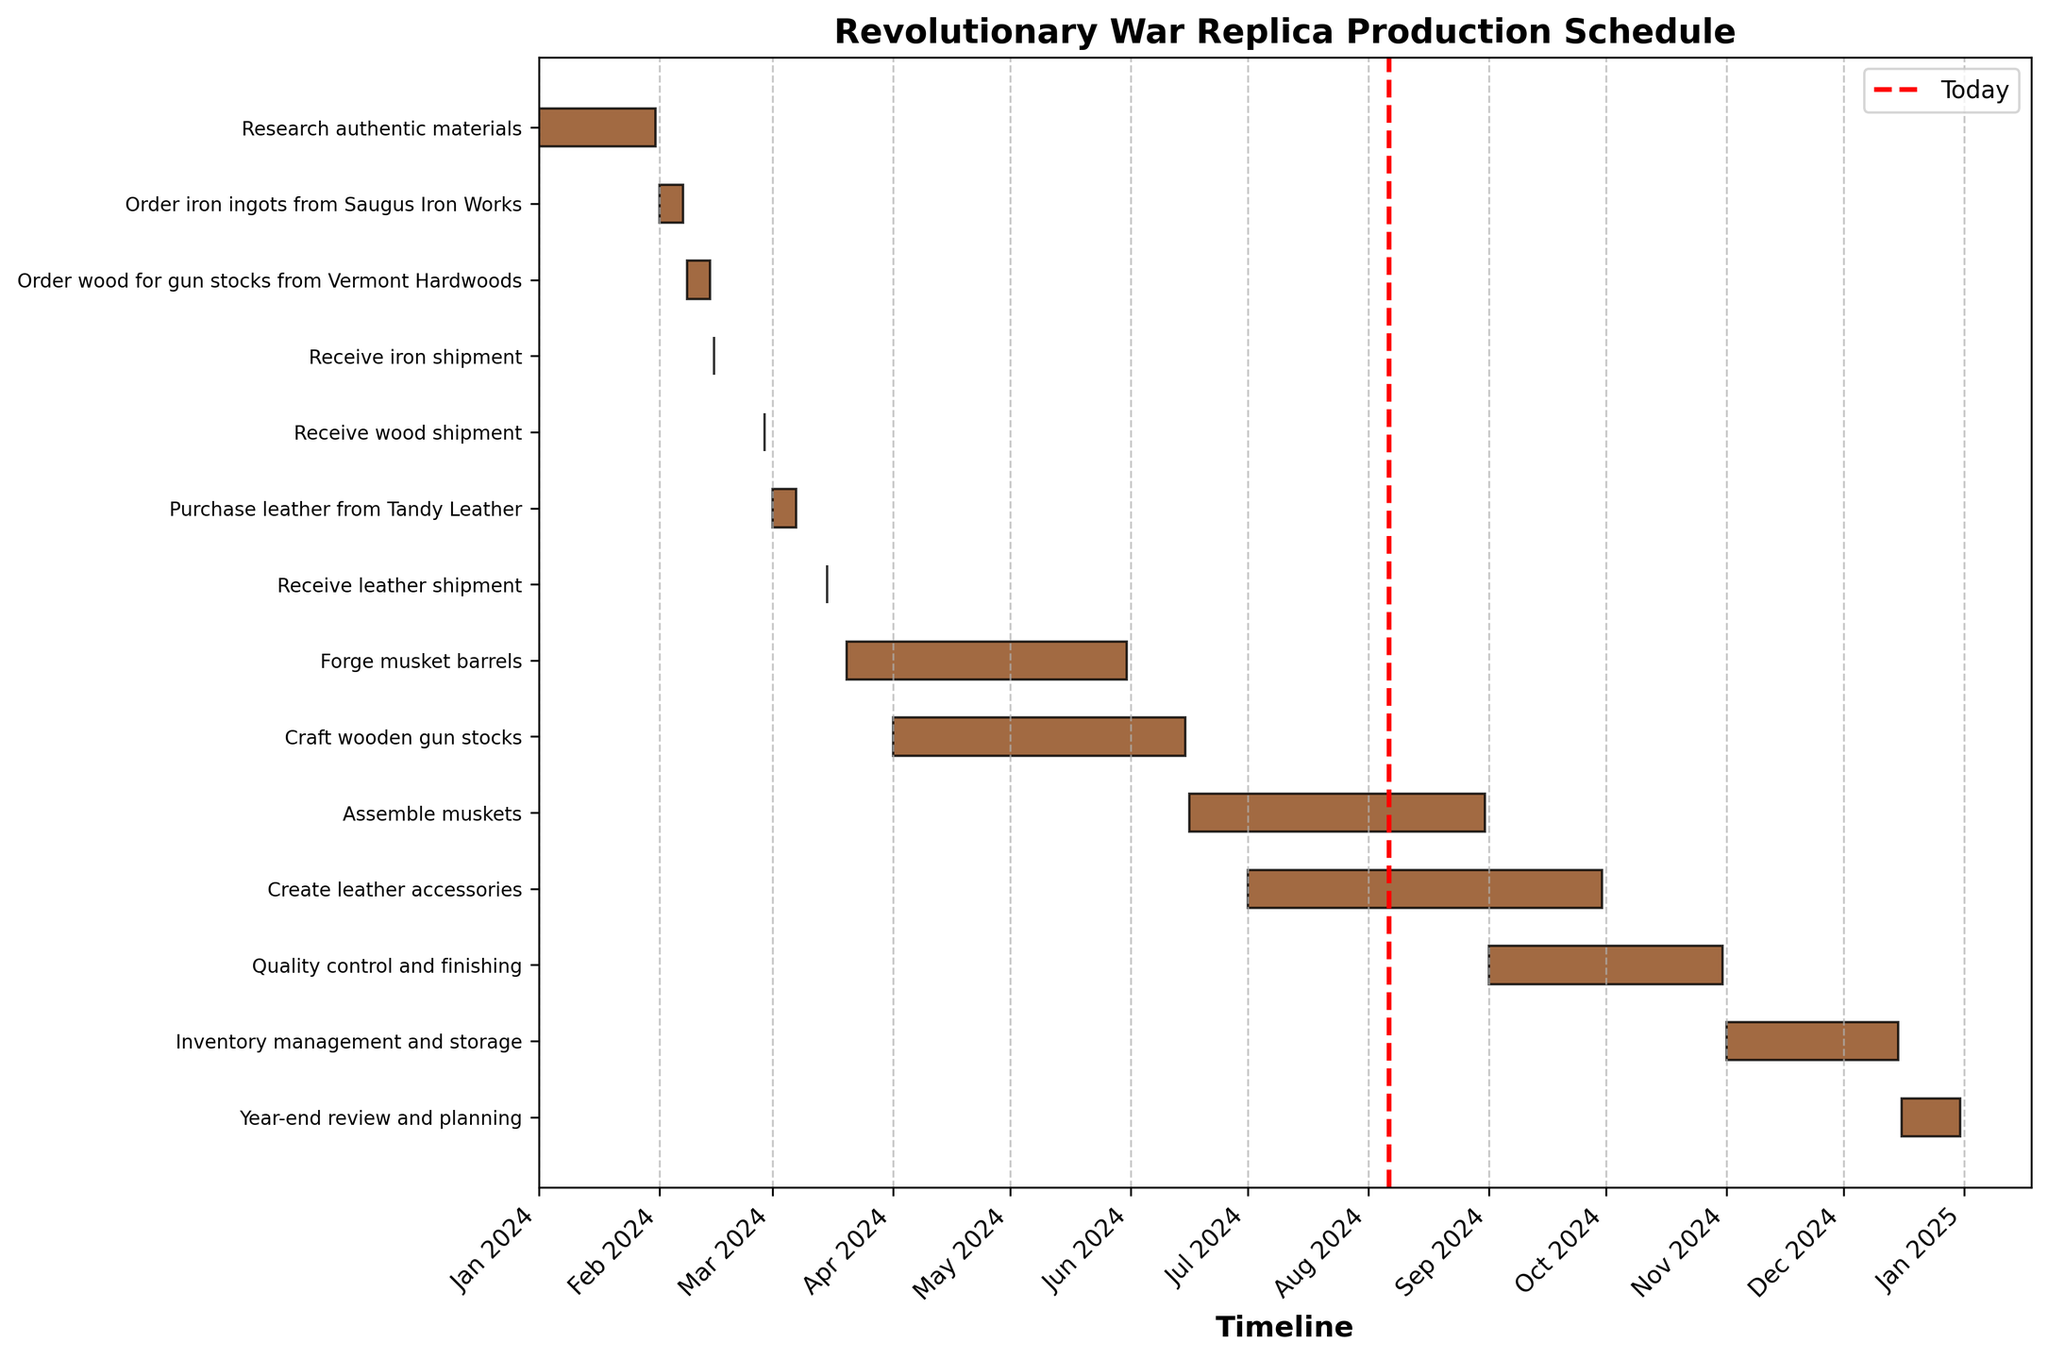What is the title of the chart? The title of the chart is usually at the top and prominently displays the main theme or subject of the visualization. It helps identify the purpose of the chart at a glance.
Answer: Revolutionary War Replica Production Schedule What are the start and end dates for the task "Forge musket barrels"? To find the start and end dates, look for the task "Forge musket barrels" on the y-axis and trace its horizontal bar to the x-axis. The bar represents the duration of the task.
Answer: 2024-03-20 to 2024-05-31 Which task takes place directly after "Research authentic materials"? To determine the task that occurs directly after "Research authentic materials," check the end date of "Research authentic materials" and see which task starts immediately after this date.
Answer: Order iron ingots from Saugus Iron Works How long does the task "Craft wooden gun stocks" last? Calculate the duration by subtracting the start date from the end date for the task "Craft wooden gun stocks." This can be observed from the horizontal bar's beginning and end on the x-axis.
Answer: 75 days How many days after "Order iron ingots from Saugus Iron Works" is the "Receive iron shipment"? Find the start and end dates for "Order iron ingots from Saugus Iron Works" and then the date for "Receive iron shipment." Calculate the difference in days between the "Receive iron shipment" date and the end date of the ordering task.
Answer: 8 days Which task has the shortest duration? Identify the shortest horizontal bar among all tasks which indicates the shortest duration by visual inspection.
Answer: Receive iron shipment, Receive wood shipment, and Receive leather shipment (all 1 day) What time of the year is allocated for "Quality control and finishing"? Identify the position of "Quality control and finishing" on the y-axis, and then trace its horizontal bar on the x-axis to determine the time frame.
Answer: September to October 2024 Which task overlaps with "Create leather accessories"? Look for tasks that have their horizontal bars extending into the start and end dates of "Create leather accessories" by examining the x-axis duration of each task.
Answer: Quality control and finishing Do "Craft wooden gun stocks" and "Forge musket barrels" overlap in time? Compare the start and end dates of the two tasks by tracing their horizontal bars on the x-axis to see if they have any overlapping period.
Answer: Yes How many tasks are scheduled before May 2024? Count the number of tasks whose start dates are before May 2024 by checking each task’s starting position on the x-axis.
Answer: 5 